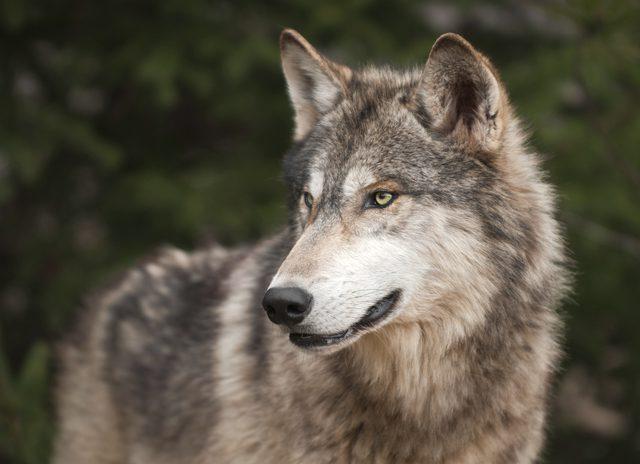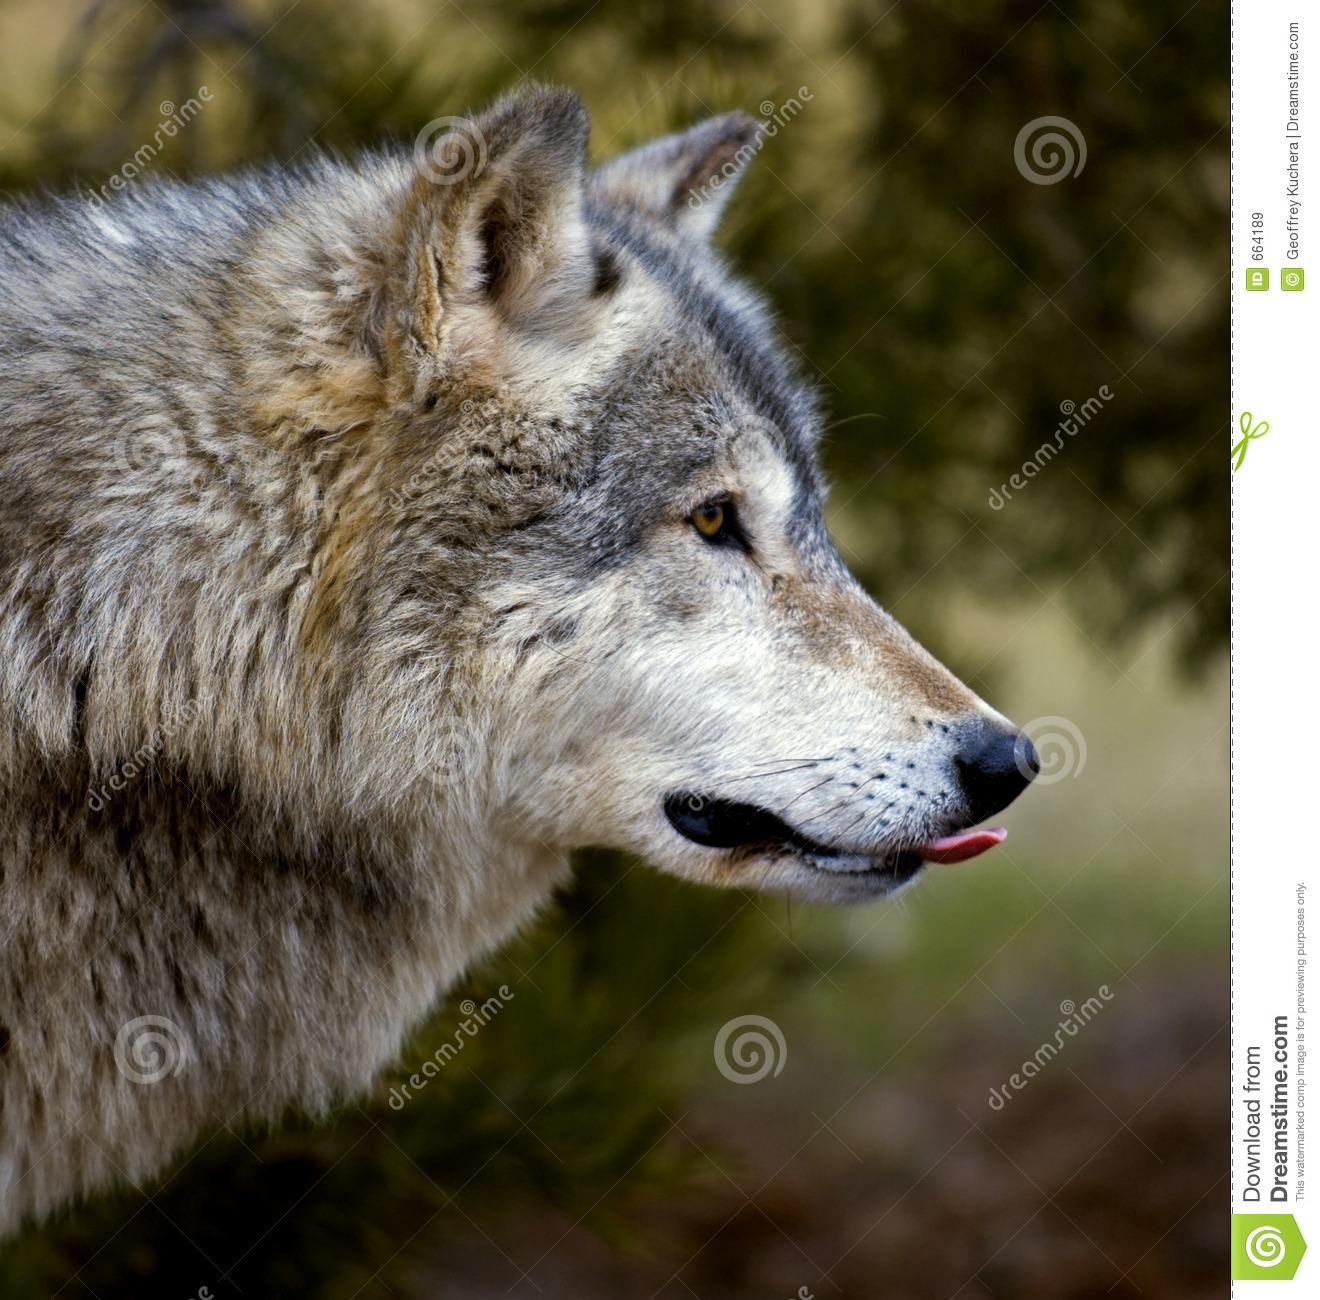The first image is the image on the left, the second image is the image on the right. Considering the images on both sides, is "The right image contains multiple animals." valid? Answer yes or no. No. The first image is the image on the left, the second image is the image on the right. Analyze the images presented: Is the assertion "There is more than one wolf in the image on the right." valid? Answer yes or no. No. 